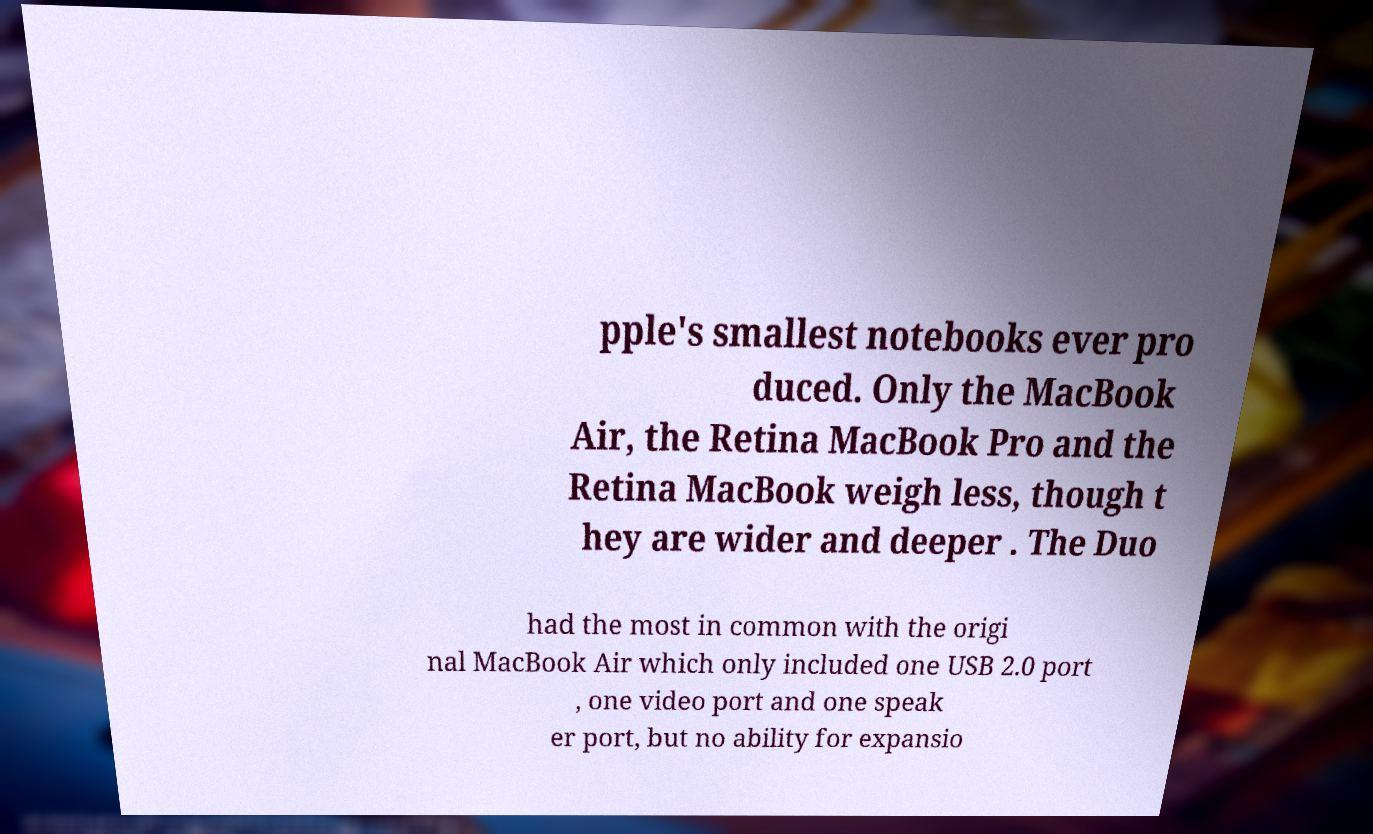What messages or text are displayed in this image? I need them in a readable, typed format. pple's smallest notebooks ever pro duced. Only the MacBook Air, the Retina MacBook Pro and the Retina MacBook weigh less, though t hey are wider and deeper . The Duo had the most in common with the origi nal MacBook Air which only included one USB 2.0 port , one video port and one speak er port, but no ability for expansio 